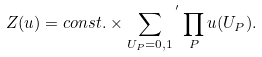Convert formula to latex. <formula><loc_0><loc_0><loc_500><loc_500>Z ( u ) = c o n s t . \times { \sum _ { U _ { P } = 0 , 1 } } ^ { \, ^ { \prime } } \prod _ { P } u ( U _ { P } ) .</formula> 